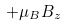<formula> <loc_0><loc_0><loc_500><loc_500>+ \mu _ { B } B _ { z }</formula> 